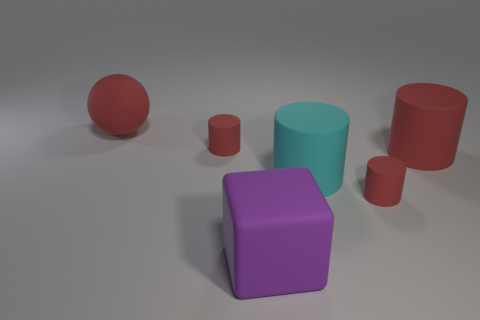Add 3 big cyan cylinders. How many objects exist? 9 Subtract all red cylinders. How many cylinders are left? 1 Subtract 0 yellow balls. How many objects are left? 6 Subtract all balls. How many objects are left? 5 Subtract 4 cylinders. How many cylinders are left? 0 Subtract all yellow balls. Subtract all cyan blocks. How many balls are left? 1 Subtract all purple spheres. How many yellow cylinders are left? 0 Subtract all tiny brown blocks. Subtract all big purple rubber cubes. How many objects are left? 5 Add 6 big cubes. How many big cubes are left? 7 Add 1 small things. How many small things exist? 3 